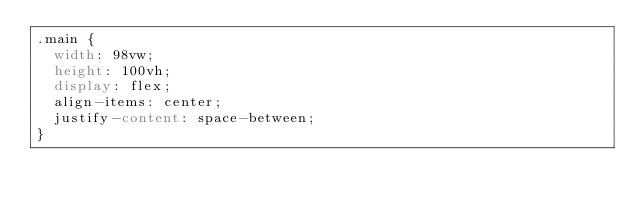<code> <loc_0><loc_0><loc_500><loc_500><_CSS_>.main {
  width: 98vw;
  height: 100vh;
  display: flex;
  align-items: center;
  justify-content: space-between;
}
</code> 